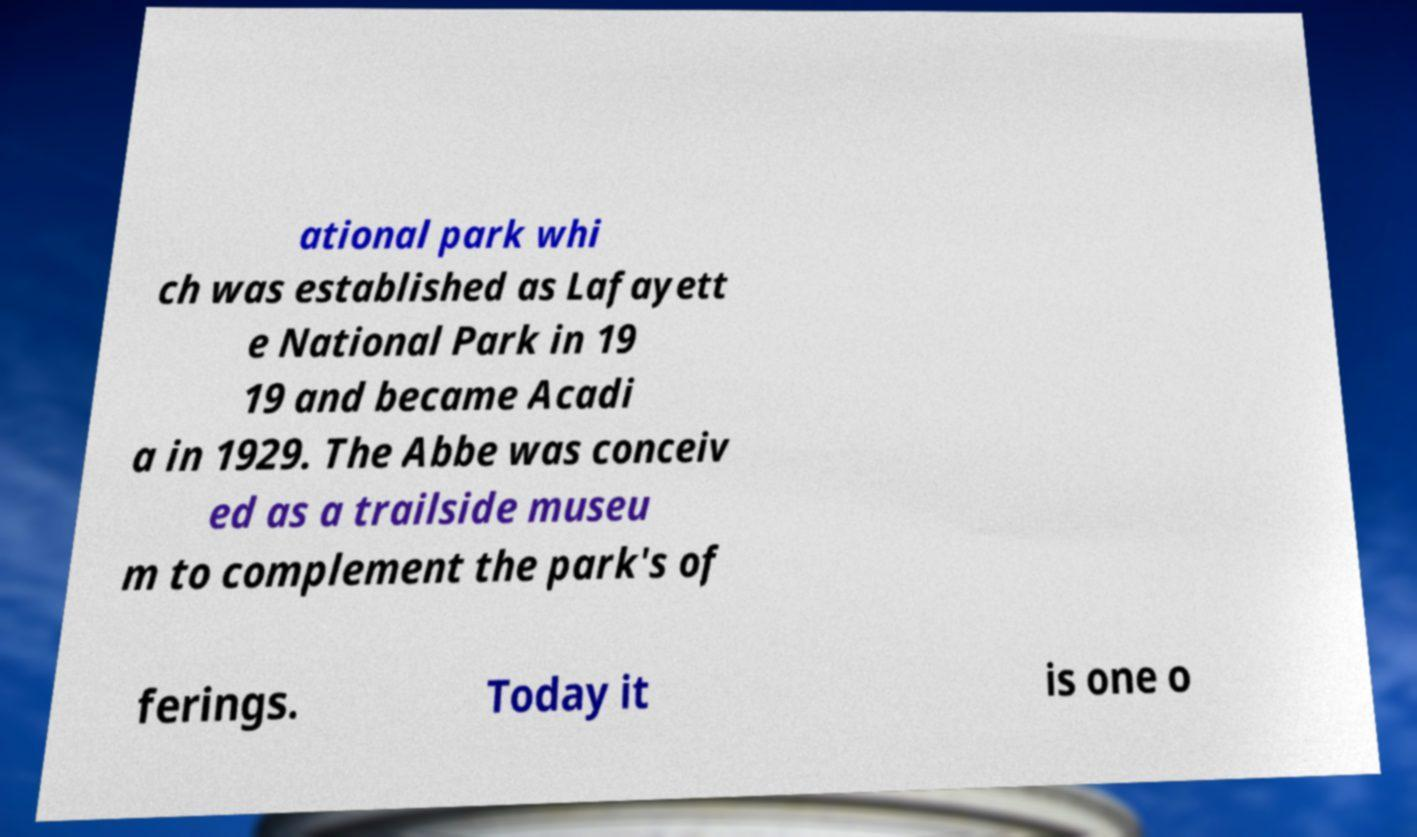Can you read and provide the text displayed in the image?This photo seems to have some interesting text. Can you extract and type it out for me? ational park whi ch was established as Lafayett e National Park in 19 19 and became Acadi a in 1929. The Abbe was conceiv ed as a trailside museu m to complement the park's of ferings. Today it is one o 